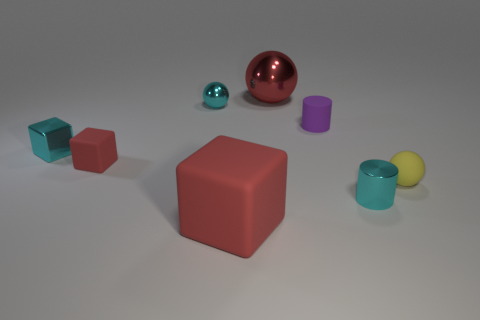What is the material of the small object that is the same color as the large metallic thing?
Give a very brief answer. Rubber. What number of other objects are there of the same material as the large red ball?
Offer a terse response. 3. The red matte thing that is the same size as the cyan cylinder is what shape?
Give a very brief answer. Cube. How many other things are there of the same shape as the large metal thing?
Your answer should be very brief. 2. Is the size of the red ball the same as the red thing in front of the small cyan cylinder?
Offer a very short reply. Yes. How many things are either metal spheres that are on the left side of the large red rubber block or large green metal cylinders?
Ensure brevity in your answer.  1. What is the shape of the tiny cyan object that is to the right of the big metal sphere?
Provide a succinct answer. Cylinder. Is the number of small cyan cylinders that are behind the small metallic sphere the same as the number of big red matte things left of the purple rubber cylinder?
Offer a very short reply. No. There is a small thing that is behind the metal cylinder and on the right side of the tiny matte cylinder; what is its color?
Your answer should be very brief. Yellow. The big object that is behind the large object that is in front of the large ball is made of what material?
Your answer should be compact. Metal. 